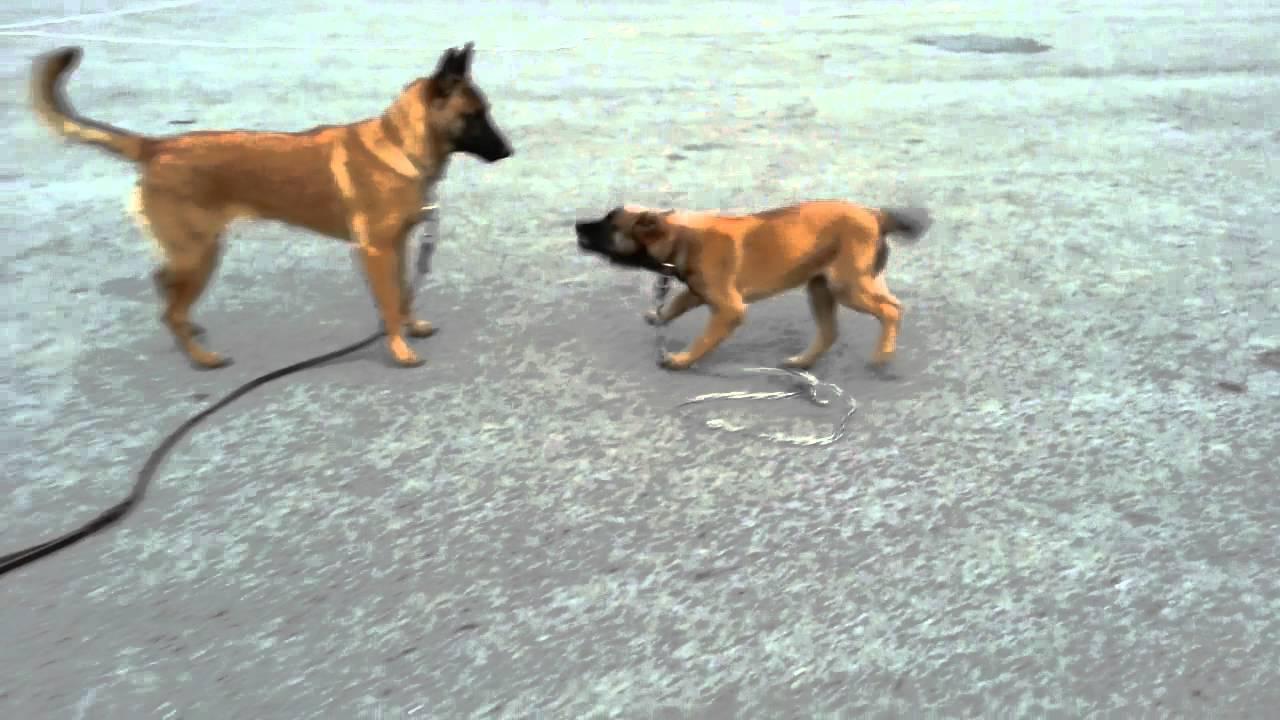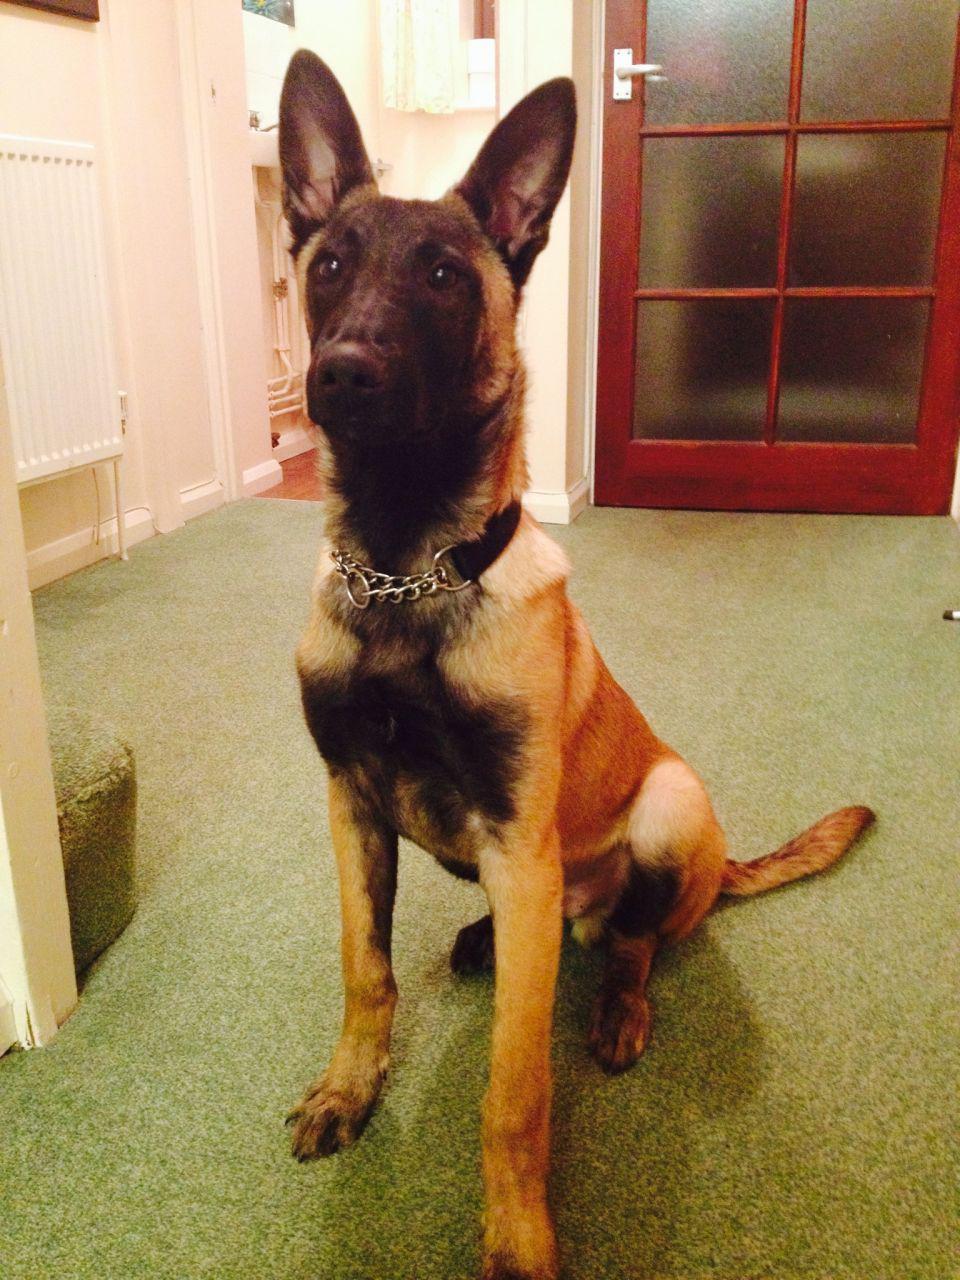The first image is the image on the left, the second image is the image on the right. Examine the images to the left and right. Is the description "An image shows only one dog, which is standing on a hard surface and wearing a leash." accurate? Answer yes or no. No. The first image is the image on the left, the second image is the image on the right. Examine the images to the left and right. Is the description "There are two dogs in total and one of them is standing on grass.›" accurate? Answer yes or no. No. 